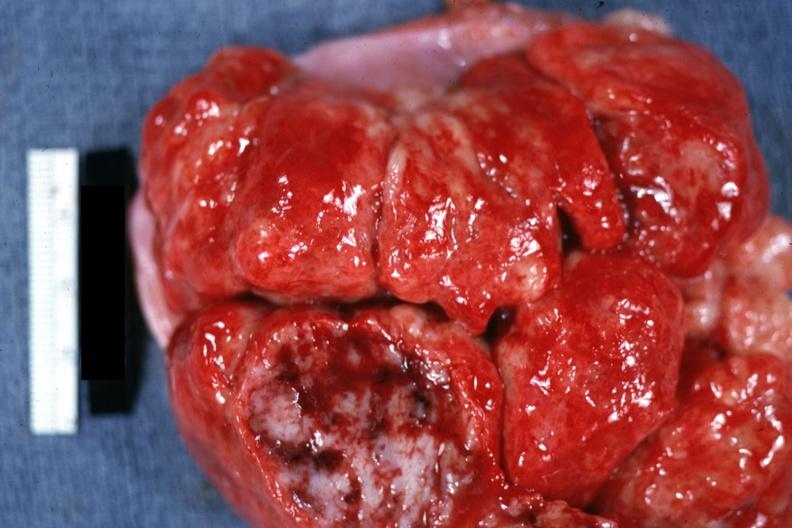how does this image show massive enlargement?
Answer the question using a single word or phrase. With necrosis shown close-up natural color 